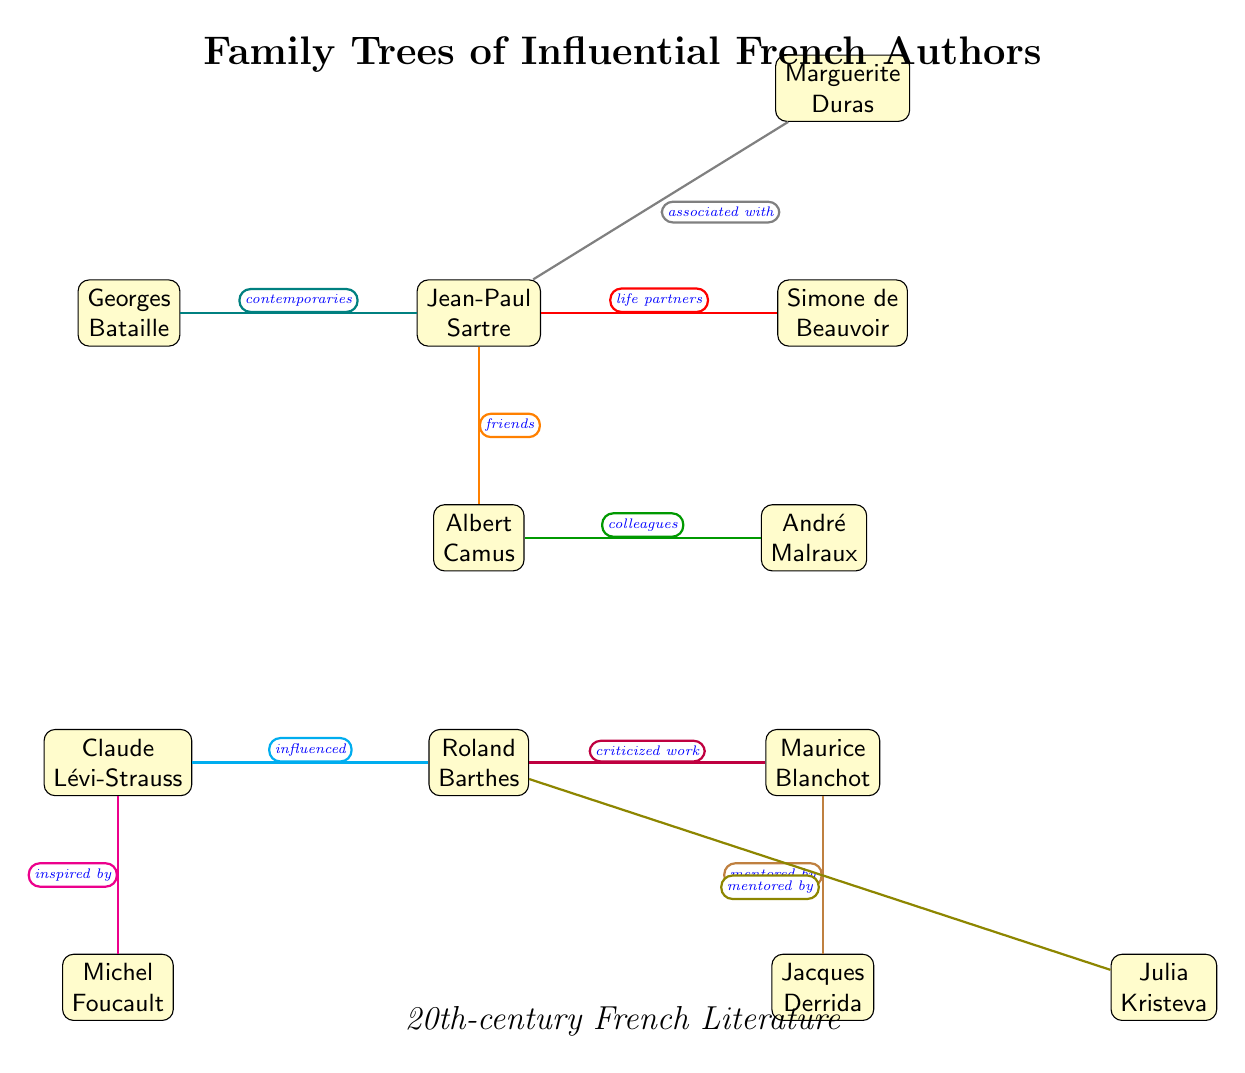What is the relationship between Jean-Paul Sartre and Simone de Beauvoir? In the diagram, Jean-Paul Sartre is connected to Simone de Beauvoir with a red arrow labeled "life partners," indicating a close personal relationship.
Answer: life partners Who is depicted as being mentored by Maurice Blanchot? The diagram shows a directed arrow from Jacques Derrida to Maurice Blanchot with the label "mentored by," indicating that Jacques Derrida was mentored by Maurice Blanchot.
Answer: Jacques Derrida How many authors are shown in the diagram? By counting the nodes in the diagram, we find a total of 10 authors listed, including Sartre, Beauvoir, Camus, Malraux, Barthes, Blanchot, Lévi-Strauss, Foucault, Derrida, Kristeva, Duras, and Bataille.
Answer: 10 What color represents the "influenced" relationship in the diagram? The diagram uses cyan to denote the "influenced" relationship, specifically connecting Claude Lévi-Strauss to Roland Barthes.
Answer: cyan Which author is described as "associated with" Sartre? The diagram connects Marguerite Duras to Jean-Paul Sartre with a gray arrow labeled "associated with," identifying Duras as associated with Sartre.
Answer: Marguerite Duras Name a pair of authors that are indicated as contemporaries. In the diagram, Georges Bataille and Jean-Paul Sartre are connected by a brown line labeled "contemporaries," showing their simultaneous presence in the literary sphere.
Answer: Georges Bataille What does the orange edge indicate about the relationship between Sartre and Camus? The orange edge between Sartre and Camus is labeled "friends," indicating that they shared a friendship and likely a collaborative relationship in their literary pursuits.
Answer: friends Who influenced Roland Barthes according to the diagram? The diagram shows Claude Lévi-Strauss influencing Roland Barthes, as depicted by a cyan edge labeled "influenced."
Answer: Claude Lévi-Strauss Which author is depicted as a critic of Blanchot? The purple edge labeled "criticized work" identifies the relationship from Roland Barthes to Maurice Blanchot, indicating that Barthes criticized Blanchot's work.
Answer: Roland Barthes 